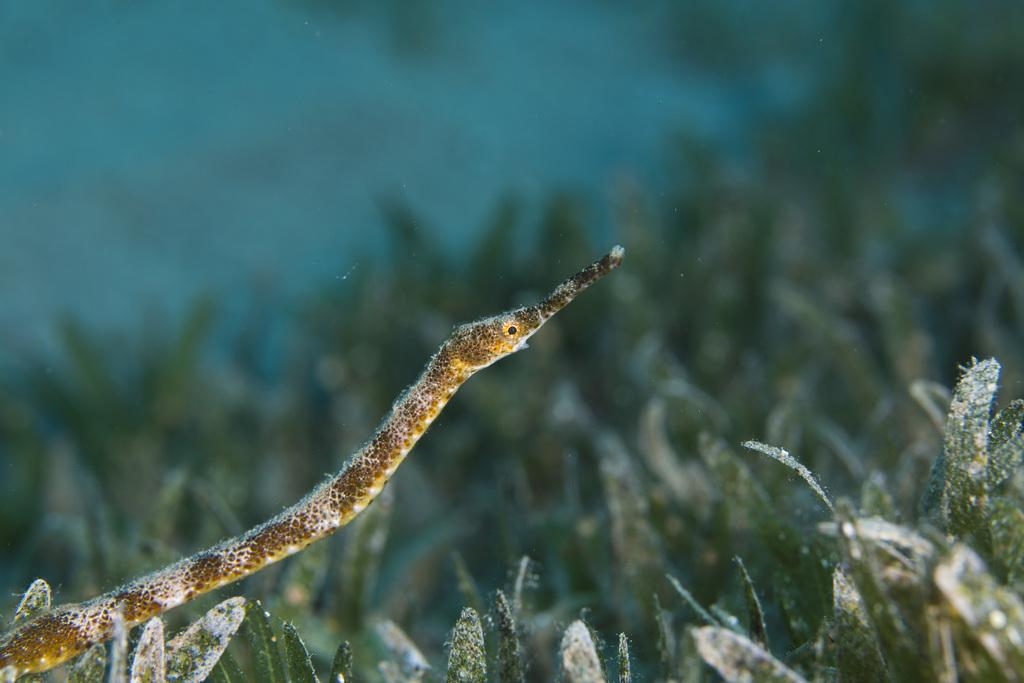What type of animal is in the image? There is an aquatic animal in the image. Where is the aquatic animal located? The aquatic animal is on a plant. Can you describe the background of the image? The background of the image is blurred. What type of cord is used to hold the glass in the image? There is no cord or glass present in the image; it features an aquatic animal on a plant with a blurred background. 